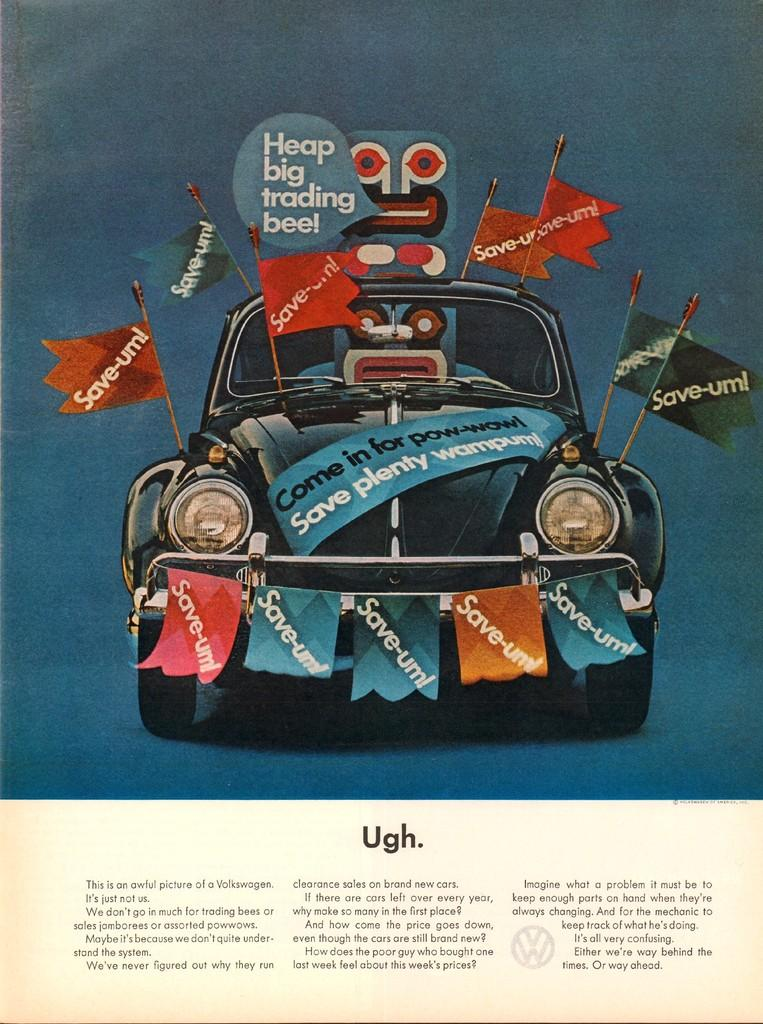What is the main subject of the image? The main subject of the image is a picture of a car. Where is the car located in the image? The car is in the middle of the image. What additional features can be seen on the car? There are flags on the car. What information is provided at the bottom of the image? There is text written at the bottom of the image. What type of reward is being given to the paper in the image? There is no paper present in the image, and therefore no reward can be given to it. 